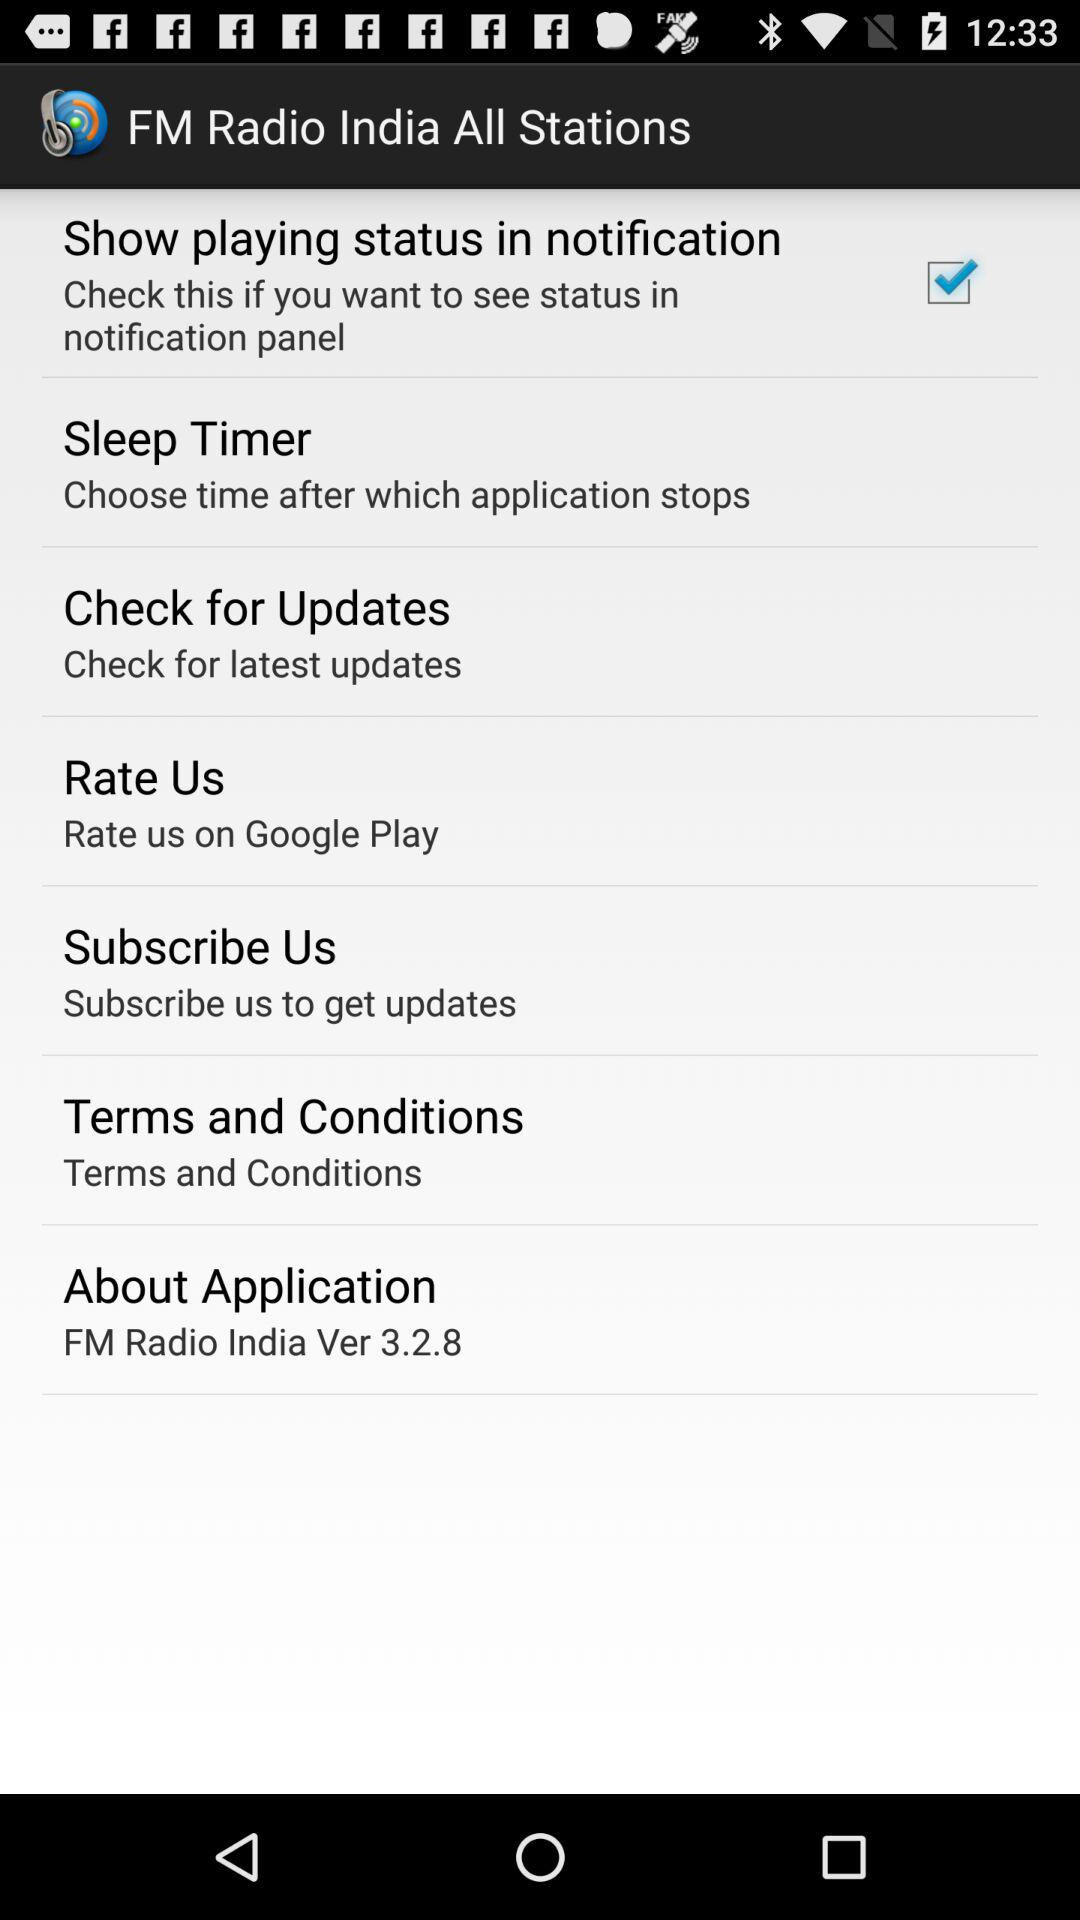What version of FM radio is used? The used version of FM radio is 3.2.8. 